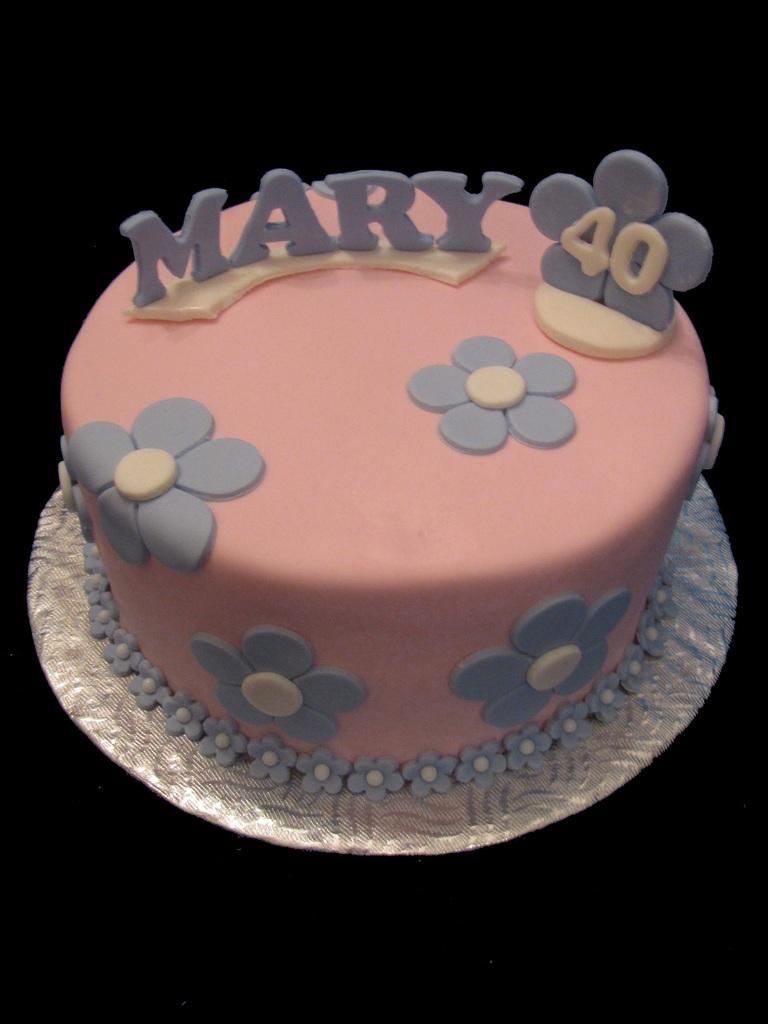Describe this image in one or two sentences. In the middle of this image, there is a pink colored cake, on which there are gray color letters and flowers placed on a silver color plate. This plate is placed on a surface. And the background is dark in color. 